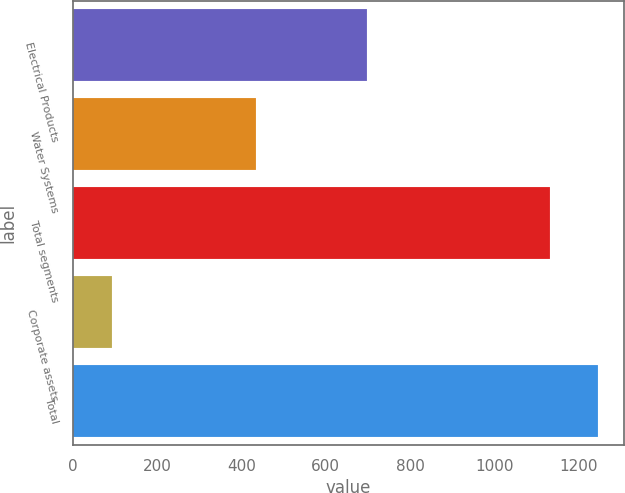<chart> <loc_0><loc_0><loc_500><loc_500><bar_chart><fcel>Electrical Products<fcel>Water Systems<fcel>Total segments<fcel>Corporate assets<fcel>Total<nl><fcel>697.4<fcel>434.7<fcel>1132.1<fcel>92.8<fcel>1245.31<nl></chart> 